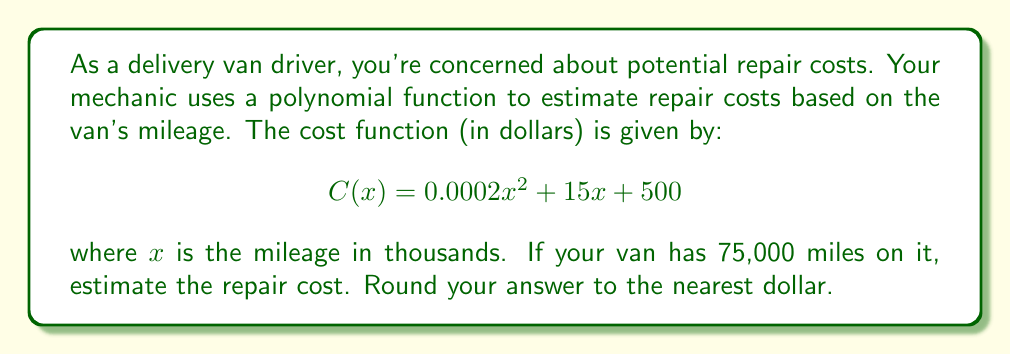Help me with this question. To solve this problem, we need to follow these steps:

1. Identify the mileage: 75,000 miles
2. Convert the mileage to thousands: 75,000 ÷ 1,000 = 75
3. Substitute x = 75 into the cost function:

   $$C(75) = 0.0002(75)^2 + 15(75) + 500$$

4. Calculate each term:
   - $0.0002(75)^2 = 0.0002 * 5625 = 1.125$
   - $15(75) = 1125$
   - $500$ remains as is

5. Sum up all terms:
   $$C(75) = 1.125 + 1125 + 500 = 1626.125$$

6. Round to the nearest dollar:
   $1626.125 ≈ 1626$

Therefore, the estimated repair cost for a van with 75,000 miles is $1,626.
Answer: $1,626 